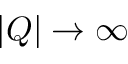<formula> <loc_0><loc_0><loc_500><loc_500>| Q | \rightarrow \infty</formula> 